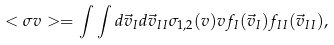<formula> <loc_0><loc_0><loc_500><loc_500>< \sigma v > = \int \int d \vec { v } _ { I } d \vec { v } _ { I I } \sigma _ { 1 , 2 } ( v ) v f _ { I } ( \vec { v } _ { I } ) f _ { I I } ( \vec { v } _ { I I } ) ,</formula> 